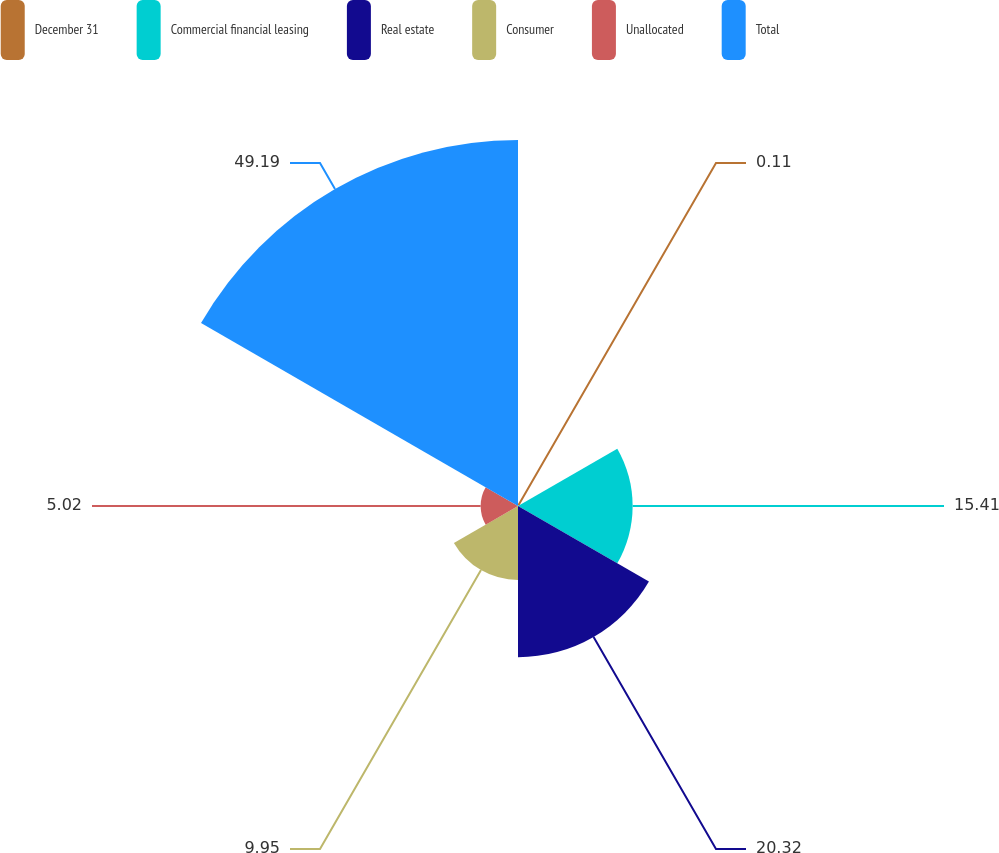Convert chart to OTSL. <chart><loc_0><loc_0><loc_500><loc_500><pie_chart><fcel>December 31<fcel>Commercial financial leasing<fcel>Real estate<fcel>Consumer<fcel>Unallocated<fcel>Total<nl><fcel>0.11%<fcel>15.41%<fcel>20.32%<fcel>9.95%<fcel>5.02%<fcel>49.2%<nl></chart> 